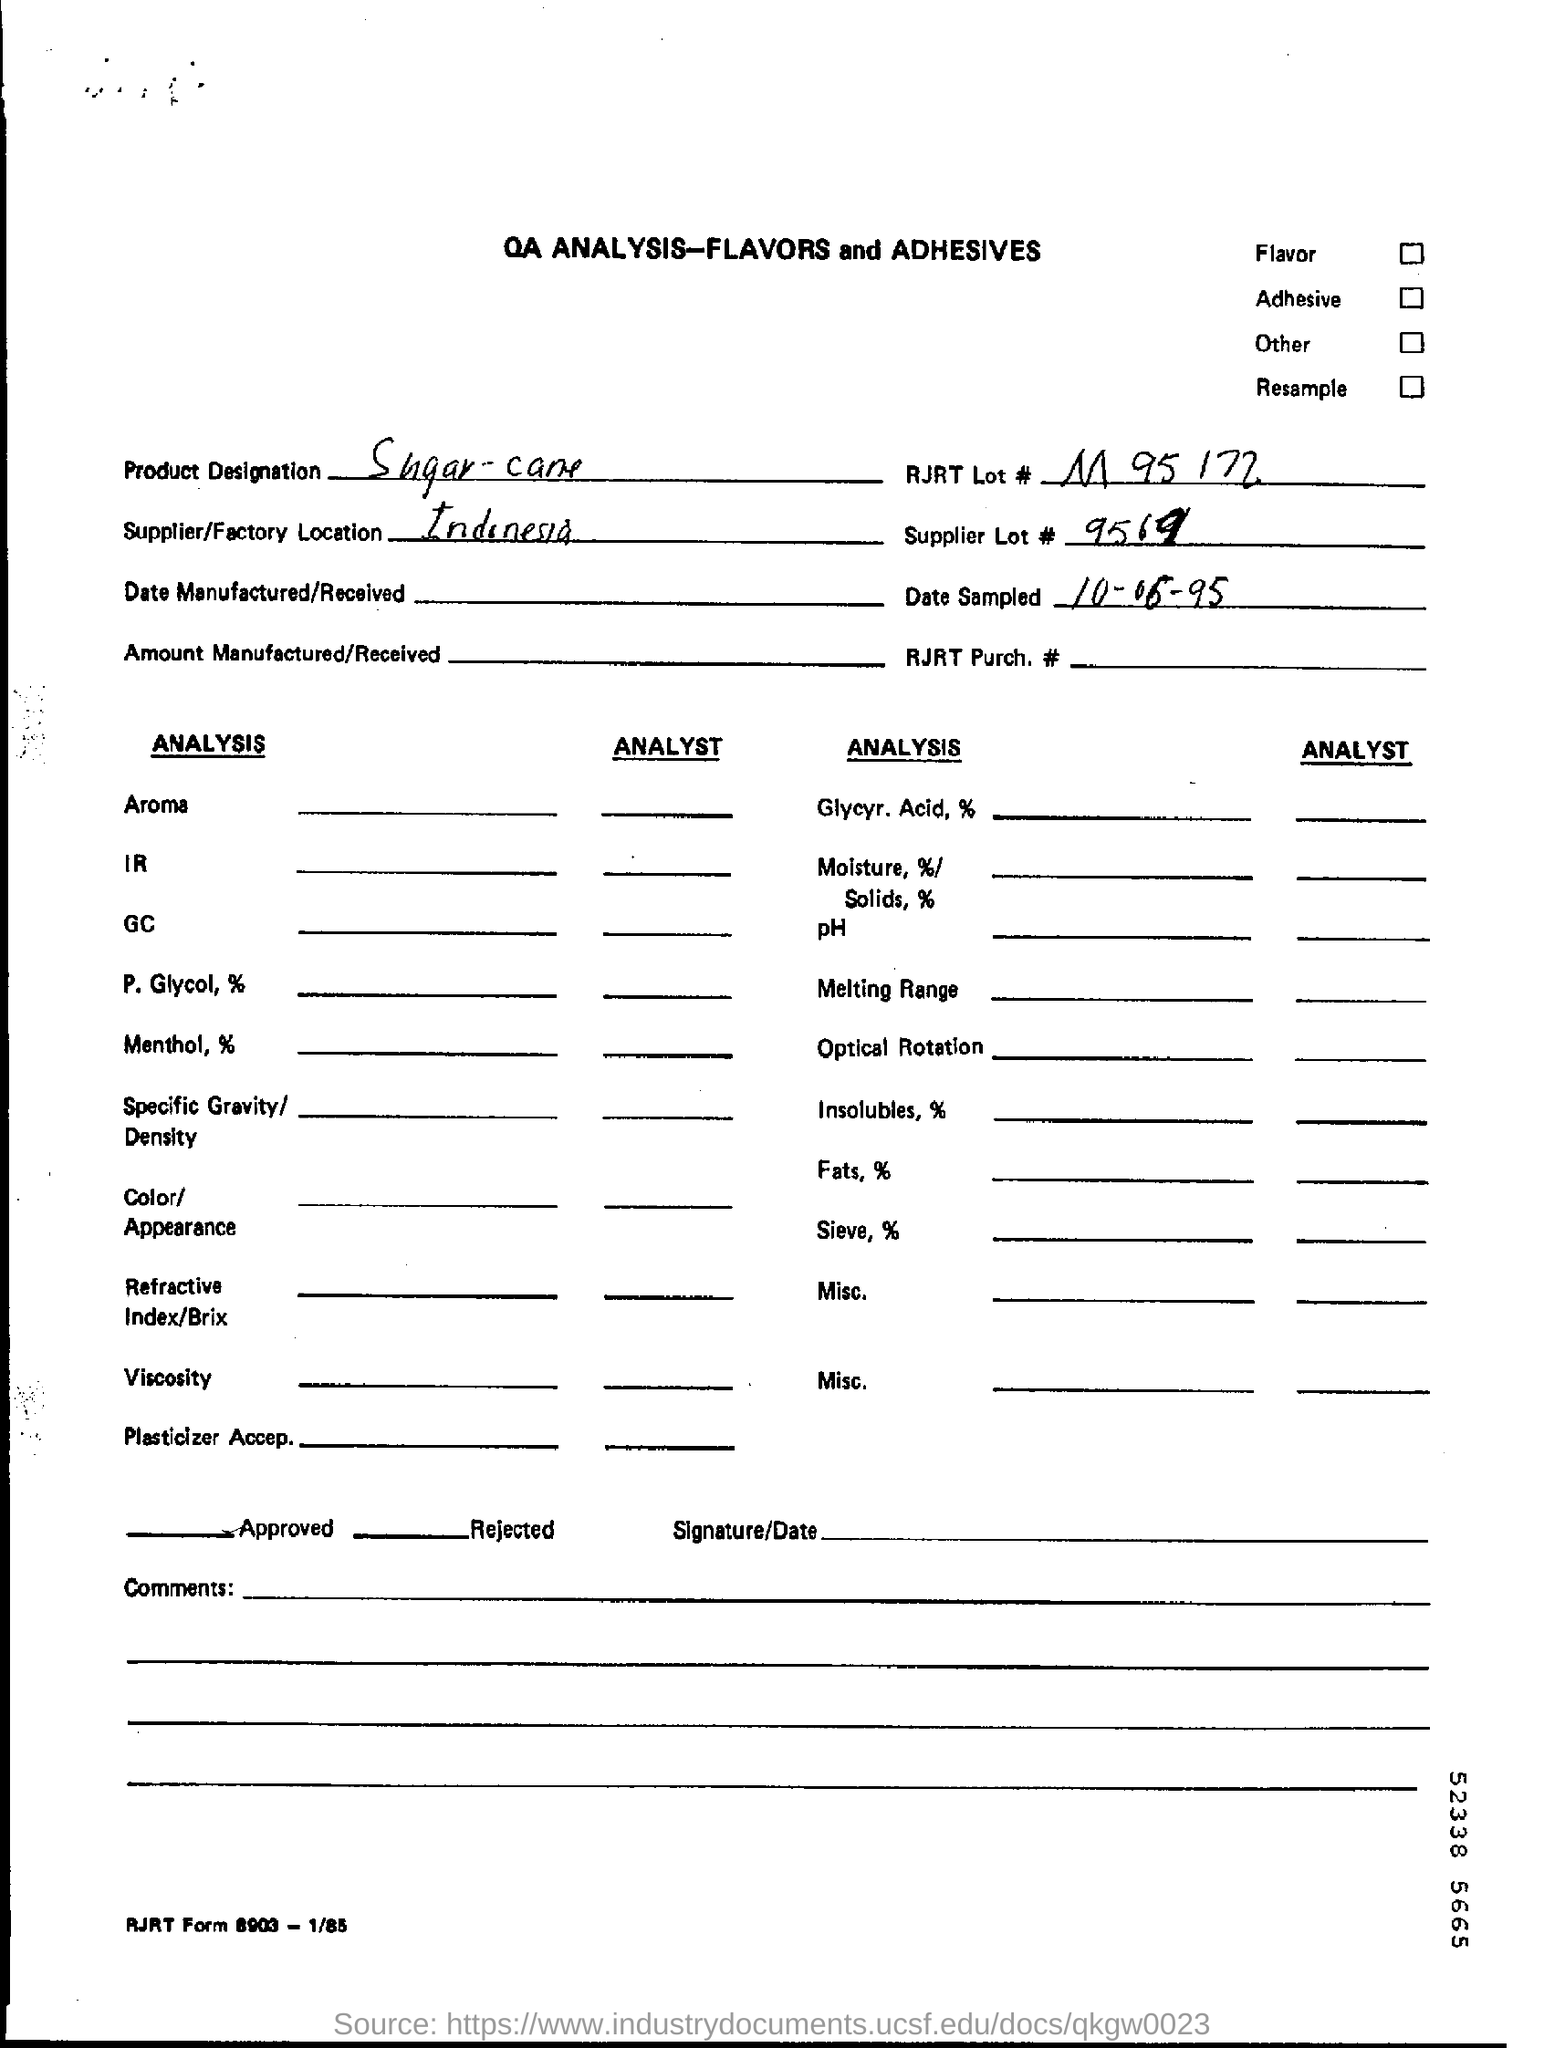List a handful of essential elements in this visual. Our supplier/factory is located in Indonesia. Please provide the product designation. The product is sugar cane. The RJRT lot number is M 95 172. A sample of a date was taken on June 10th, 1995. The supplier lot number is 9569... 